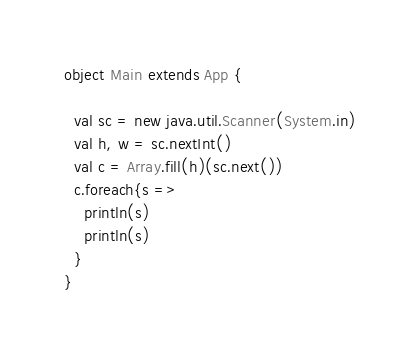Convert code to text. <code><loc_0><loc_0><loc_500><loc_500><_Scala_>
object Main extends App {
  
  val sc = new java.util.Scanner(System.in)
  val h, w = sc.nextInt()
  val c = Array.fill(h)(sc.next())
  c.foreach{s =>
    println(s)
    println(s)
  }
}</code> 